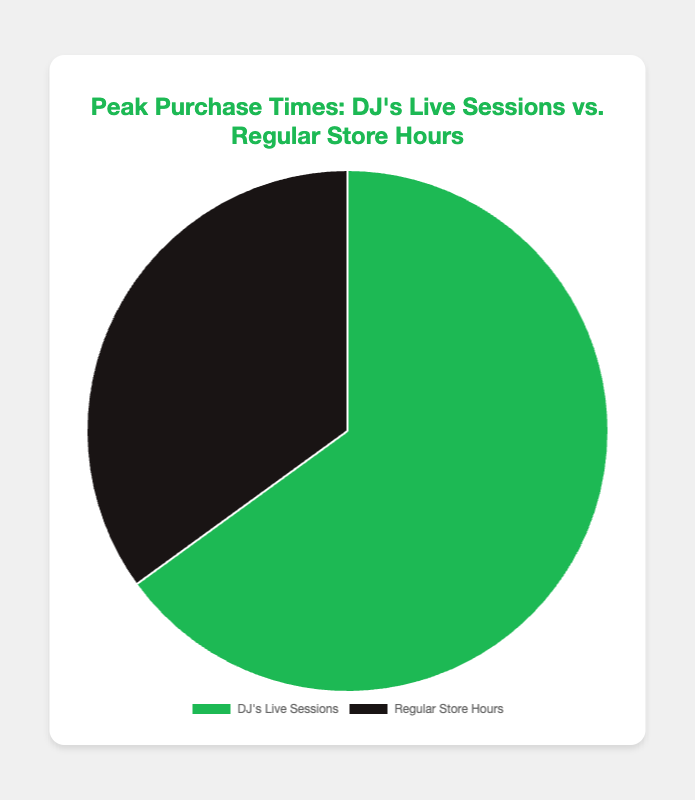What percentage of peak purchases happens during DJ's live sessions? The pie chart shows two segments: one for DJ's live sessions at 65% and one for regular store hours at 35%. Hence, the percentage of peak purchases during DJ's live sessions is 65%.
Answer: 65% What is the difference in percentage points between peak purchases during DJ's live sessions and regular store hours? The percentage for DJ's live sessions is 65%, and for regular store hours, it is 35%. The difference is calculated as 65% - 35% = 30%.
Answer: 30% How much more popular are DJ's live sessions compared to regular store hours in terms of peak purchase times? The percentage for DJ's live sessions is 65%, and for regular store hours, it is 35%. To find how much more popular DJ's live sessions are, divide 65% by 35%, resulting in approximately 1.86. This means DJ's live sessions are 86% more popular.
Answer: 86% What fraction of peak purchases occurs during regular store hours? The percentage for regular store hours is 35%. To convert this to a fraction, divide 35 by 100, resulting in 35/100 or simplified to 7/20.
Answer: 7/20 Which time period has the higher percentage of peak purchases? Comparing the pie chart segments, DJ's live sessions have 65%, and regular store hours have 35%. Therefore, DJ's live sessions have the higher percentage.
Answer: DJ's live sessions If the percentage of peak purchases during regular store hours doubled, what would the new percentage be? The original percentage for regular store hours is 35%. If it doubles, then it would be 35% * 2, which equals 70%.
Answer: 70% What colors are used to represent DJ's live sessions and regular store hours? The pie chart uses green to represent DJ's live sessions and black to represent regular store hours.
Answer: green for DJ's live sessions, black for regular store hours If the total number of peak purchases is 100, how many of them occur during DJ's live sessions? Given the total number of peak purchases is 100, 65% of these occur during DJ's live sessions. Therefore, the number is 65% of 100, which is 65 purchases.
Answer: 65 